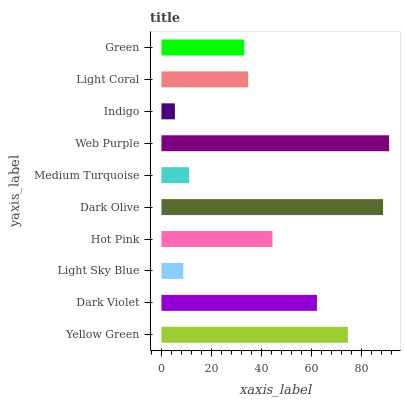Is Indigo the minimum?
Answer yes or no. Yes. Is Web Purple the maximum?
Answer yes or no. Yes. Is Dark Violet the minimum?
Answer yes or no. No. Is Dark Violet the maximum?
Answer yes or no. No. Is Yellow Green greater than Dark Violet?
Answer yes or no. Yes. Is Dark Violet less than Yellow Green?
Answer yes or no. Yes. Is Dark Violet greater than Yellow Green?
Answer yes or no. No. Is Yellow Green less than Dark Violet?
Answer yes or no. No. Is Hot Pink the high median?
Answer yes or no. Yes. Is Light Coral the low median?
Answer yes or no. Yes. Is Medium Turquoise the high median?
Answer yes or no. No. Is Green the low median?
Answer yes or no. No. 